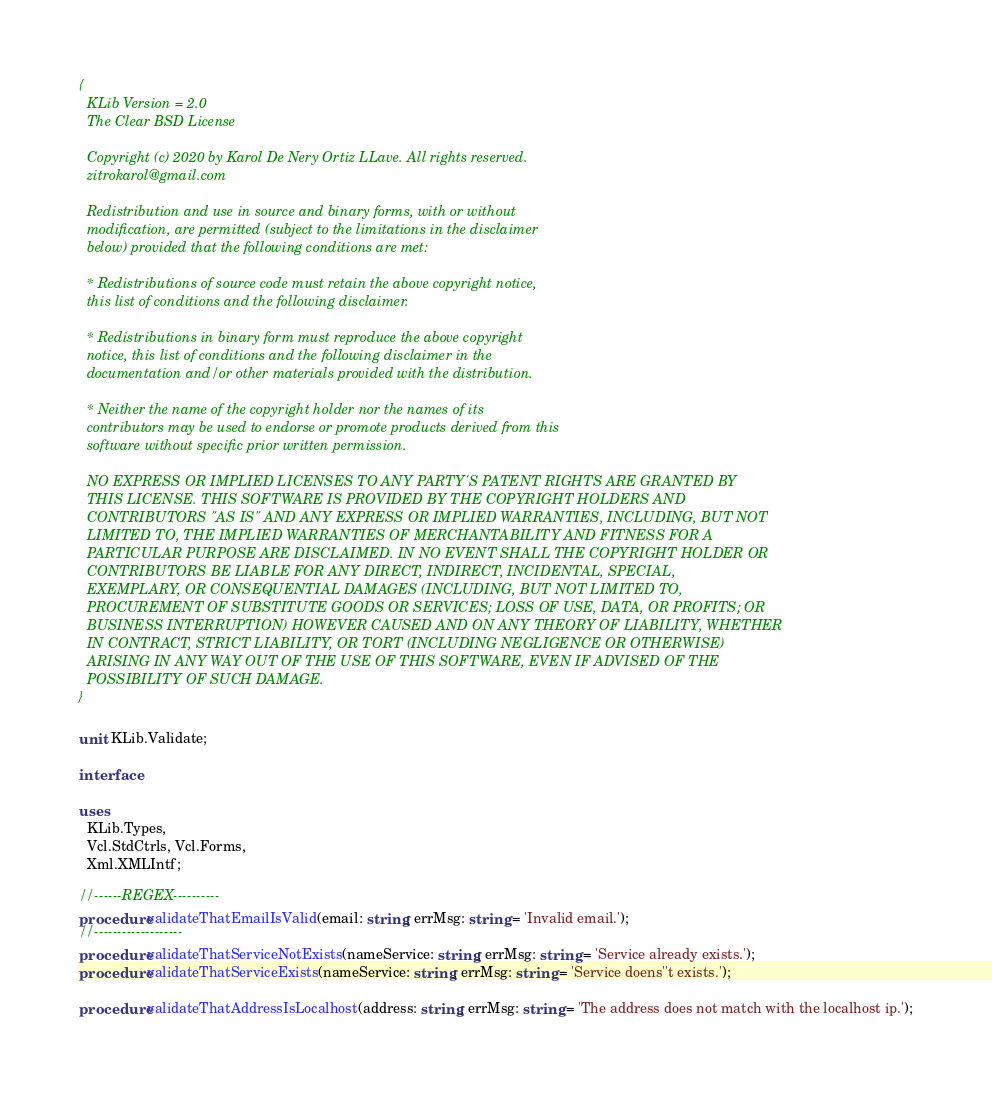Convert code to text. <code><loc_0><loc_0><loc_500><loc_500><_Pascal_>{
  KLib Version = 2.0
  The Clear BSD License

  Copyright (c) 2020 by Karol De Nery Ortiz LLave. All rights reserved.
  zitrokarol@gmail.com

  Redistribution and use in source and binary forms, with or without
  modification, are permitted (subject to the limitations in the disclaimer
  below) provided that the following conditions are met:

  * Redistributions of source code must retain the above copyright notice,
  this list of conditions and the following disclaimer.

  * Redistributions in binary form must reproduce the above copyright
  notice, this list of conditions and the following disclaimer in the
  documentation and/or other materials provided with the distribution.

  * Neither the name of the copyright holder nor the names of its
  contributors may be used to endorse or promote products derived from this
  software without specific prior written permission.

  NO EXPRESS OR IMPLIED LICENSES TO ANY PARTY'S PATENT RIGHTS ARE GRANTED BY
  THIS LICENSE. THIS SOFTWARE IS PROVIDED BY THE COPYRIGHT HOLDERS AND
  CONTRIBUTORS "AS IS" AND ANY EXPRESS OR IMPLIED WARRANTIES, INCLUDING, BUT NOT
  LIMITED TO, THE IMPLIED WARRANTIES OF MERCHANTABILITY AND FITNESS FOR A
  PARTICULAR PURPOSE ARE DISCLAIMED. IN NO EVENT SHALL THE COPYRIGHT HOLDER OR
  CONTRIBUTORS BE LIABLE FOR ANY DIRECT, INDIRECT, INCIDENTAL, SPECIAL,
  EXEMPLARY, OR CONSEQUENTIAL DAMAGES (INCLUDING, BUT NOT LIMITED TO,
  PROCUREMENT OF SUBSTITUTE GOODS OR SERVICES; LOSS OF USE, DATA, OR PROFITS; OR
  BUSINESS INTERRUPTION) HOWEVER CAUSED AND ON ANY THEORY OF LIABILITY, WHETHER
  IN CONTRACT, STRICT LIABILITY, OR TORT (INCLUDING NEGLIGENCE OR OTHERWISE)
  ARISING IN ANY WAY OUT OF THE USE OF THIS SOFTWARE, EVEN IF ADVISED OF THE
  POSSIBILITY OF SUCH DAMAGE.
}

unit KLib.Validate;

interface

uses
  KLib.Types,
  Vcl.StdCtrls, Vcl.Forms,
  Xml.XMLIntf;

//------REGEX----------
procedure validateThatEmailIsValid(email: string; errMsg: string = 'Invalid email.');
//-------------------
procedure validateThatServiceNotExists(nameService: string; errMsg: string = 'Service already exists.');
procedure validateThatServiceExists(nameService: string; errMsg: string = 'Service doens''t exists.');

procedure validateThatAddressIsLocalhost(address: string; errMsg: string = 'The address does not match with the localhost ip.');</code> 